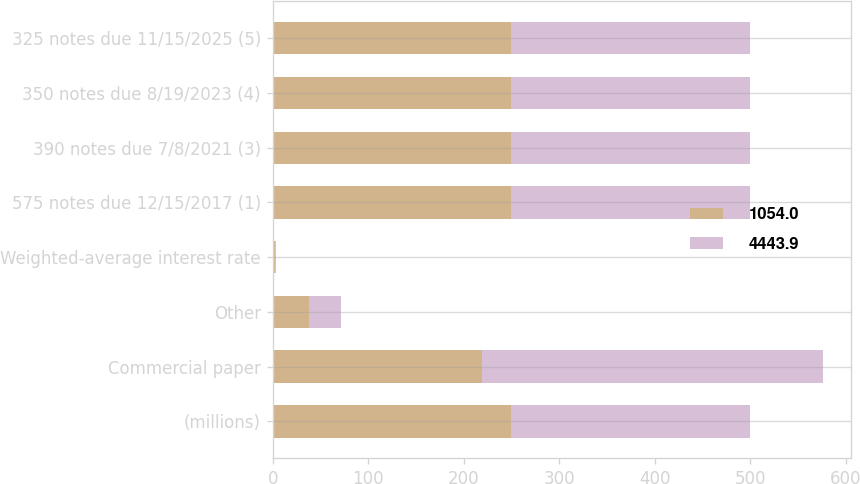Convert chart. <chart><loc_0><loc_0><loc_500><loc_500><stacked_bar_chart><ecel><fcel>(millions)<fcel>Commercial paper<fcel>Other<fcel>Weighted-average interest rate<fcel>575 notes due 12/15/2017 (1)<fcel>390 notes due 7/8/2021 (3)<fcel>350 notes due 8/19/2023 (4)<fcel>325 notes due 11/15/2025 (5)<nl><fcel>1054<fcel>250<fcel>219.4<fcel>38.2<fcel>2.3<fcel>250<fcel>250<fcel>250<fcel>250<nl><fcel>4443.9<fcel>250<fcel>356.9<fcel>33.4<fcel>1.4<fcel>250<fcel>250<fcel>250<fcel>250<nl></chart> 